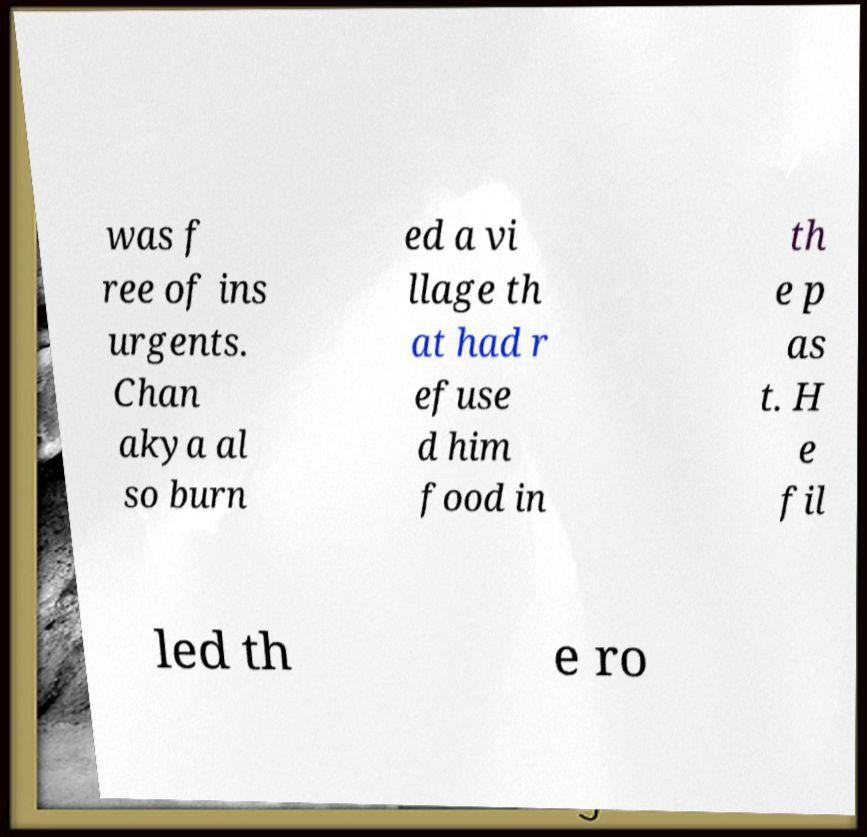What messages or text are displayed in this image? I need them in a readable, typed format. was f ree of ins urgents. Chan akya al so burn ed a vi llage th at had r efuse d him food in th e p as t. H e fil led th e ro 